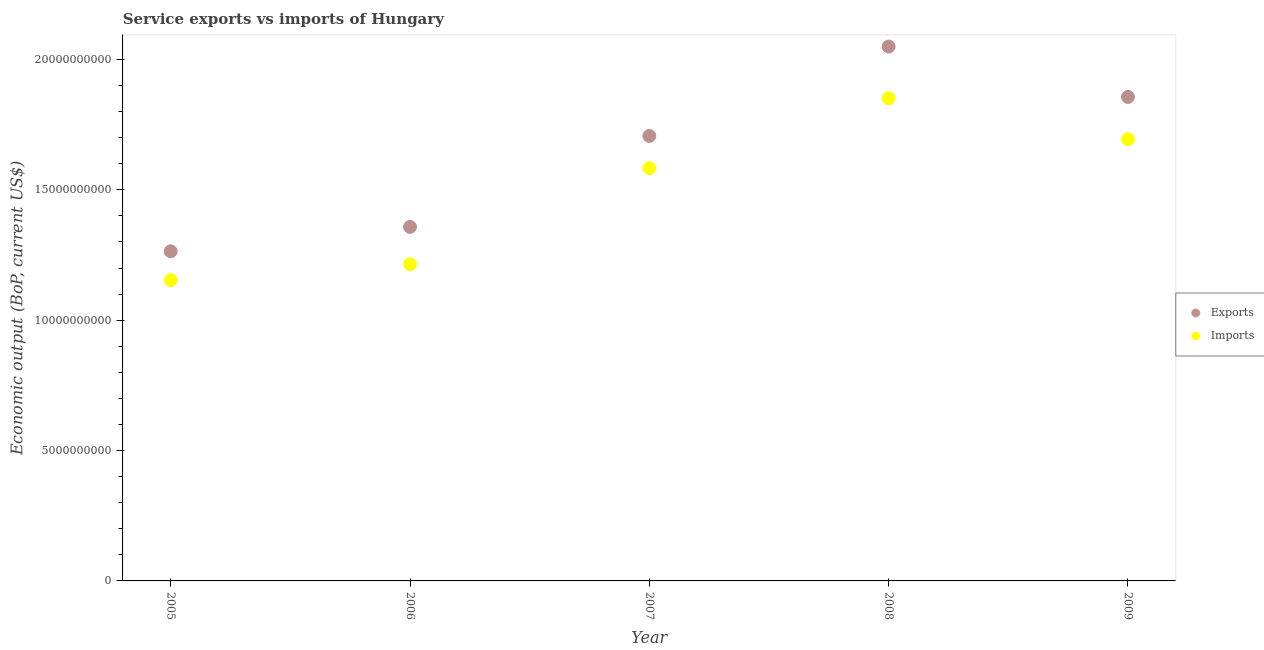How many different coloured dotlines are there?
Provide a short and direct response. 2. What is the amount of service imports in 2005?
Your answer should be very brief. 1.15e+1. Across all years, what is the maximum amount of service imports?
Offer a very short reply. 1.85e+1. Across all years, what is the minimum amount of service imports?
Your answer should be very brief. 1.15e+1. In which year was the amount of service imports minimum?
Your answer should be very brief. 2005. What is the total amount of service exports in the graph?
Your answer should be compact. 8.23e+1. What is the difference between the amount of service exports in 2005 and that in 2006?
Offer a terse response. -9.35e+08. What is the difference between the amount of service exports in 2007 and the amount of service imports in 2006?
Your answer should be compact. 4.92e+09. What is the average amount of service imports per year?
Make the answer very short. 1.50e+1. In the year 2009, what is the difference between the amount of service exports and amount of service imports?
Offer a very short reply. 1.62e+09. What is the ratio of the amount of service exports in 2006 to that in 2007?
Provide a short and direct response. 0.8. Is the difference between the amount of service imports in 2006 and 2008 greater than the difference between the amount of service exports in 2006 and 2008?
Offer a very short reply. Yes. What is the difference between the highest and the second highest amount of service imports?
Give a very brief answer. 1.57e+09. What is the difference between the highest and the lowest amount of service imports?
Keep it short and to the point. 6.98e+09. Is the sum of the amount of service imports in 2005 and 2007 greater than the maximum amount of service exports across all years?
Offer a very short reply. Yes. Is the amount of service exports strictly greater than the amount of service imports over the years?
Provide a succinct answer. Yes. Are the values on the major ticks of Y-axis written in scientific E-notation?
Give a very brief answer. No. Does the graph contain any zero values?
Offer a terse response. No. Does the graph contain grids?
Your answer should be compact. No. Where does the legend appear in the graph?
Provide a short and direct response. Center right. How many legend labels are there?
Your answer should be compact. 2. What is the title of the graph?
Offer a terse response. Service exports vs imports of Hungary. Does "Secondary" appear as one of the legend labels in the graph?
Offer a very short reply. No. What is the label or title of the X-axis?
Your answer should be compact. Year. What is the label or title of the Y-axis?
Ensure brevity in your answer.  Economic output (BoP, current US$). What is the Economic output (BoP, current US$) in Exports in 2005?
Ensure brevity in your answer.  1.26e+1. What is the Economic output (BoP, current US$) of Imports in 2005?
Keep it short and to the point. 1.15e+1. What is the Economic output (BoP, current US$) in Exports in 2006?
Your answer should be compact. 1.36e+1. What is the Economic output (BoP, current US$) of Imports in 2006?
Your response must be concise. 1.21e+1. What is the Economic output (BoP, current US$) of Exports in 2007?
Offer a very short reply. 1.71e+1. What is the Economic output (BoP, current US$) in Imports in 2007?
Provide a succinct answer. 1.58e+1. What is the Economic output (BoP, current US$) in Exports in 2008?
Your answer should be very brief. 2.05e+1. What is the Economic output (BoP, current US$) in Imports in 2008?
Offer a very short reply. 1.85e+1. What is the Economic output (BoP, current US$) in Exports in 2009?
Make the answer very short. 1.86e+1. What is the Economic output (BoP, current US$) in Imports in 2009?
Your answer should be very brief. 1.69e+1. Across all years, what is the maximum Economic output (BoP, current US$) in Exports?
Offer a terse response. 2.05e+1. Across all years, what is the maximum Economic output (BoP, current US$) in Imports?
Your response must be concise. 1.85e+1. Across all years, what is the minimum Economic output (BoP, current US$) in Exports?
Give a very brief answer. 1.26e+1. Across all years, what is the minimum Economic output (BoP, current US$) in Imports?
Your answer should be compact. 1.15e+1. What is the total Economic output (BoP, current US$) in Exports in the graph?
Your answer should be very brief. 8.23e+1. What is the total Economic output (BoP, current US$) of Imports in the graph?
Ensure brevity in your answer.  7.50e+1. What is the difference between the Economic output (BoP, current US$) of Exports in 2005 and that in 2006?
Make the answer very short. -9.35e+08. What is the difference between the Economic output (BoP, current US$) of Imports in 2005 and that in 2006?
Provide a succinct answer. -6.10e+08. What is the difference between the Economic output (BoP, current US$) of Exports in 2005 and that in 2007?
Your answer should be very brief. -4.42e+09. What is the difference between the Economic output (BoP, current US$) of Imports in 2005 and that in 2007?
Give a very brief answer. -4.30e+09. What is the difference between the Economic output (BoP, current US$) of Exports in 2005 and that in 2008?
Provide a short and direct response. -7.85e+09. What is the difference between the Economic output (BoP, current US$) in Imports in 2005 and that in 2008?
Your response must be concise. -6.98e+09. What is the difference between the Economic output (BoP, current US$) in Exports in 2005 and that in 2009?
Your answer should be compact. -5.92e+09. What is the difference between the Economic output (BoP, current US$) of Imports in 2005 and that in 2009?
Your answer should be very brief. -5.40e+09. What is the difference between the Economic output (BoP, current US$) in Exports in 2006 and that in 2007?
Your answer should be very brief. -3.49e+09. What is the difference between the Economic output (BoP, current US$) in Imports in 2006 and that in 2007?
Make the answer very short. -3.69e+09. What is the difference between the Economic output (BoP, current US$) of Exports in 2006 and that in 2008?
Your response must be concise. -6.92e+09. What is the difference between the Economic output (BoP, current US$) in Imports in 2006 and that in 2008?
Give a very brief answer. -6.37e+09. What is the difference between the Economic output (BoP, current US$) of Exports in 2006 and that in 2009?
Your answer should be compact. -4.98e+09. What is the difference between the Economic output (BoP, current US$) of Imports in 2006 and that in 2009?
Keep it short and to the point. -4.79e+09. What is the difference between the Economic output (BoP, current US$) in Exports in 2007 and that in 2008?
Your response must be concise. -3.43e+09. What is the difference between the Economic output (BoP, current US$) in Imports in 2007 and that in 2008?
Provide a short and direct response. -2.68e+09. What is the difference between the Economic output (BoP, current US$) of Exports in 2007 and that in 2009?
Provide a succinct answer. -1.50e+09. What is the difference between the Economic output (BoP, current US$) of Imports in 2007 and that in 2009?
Your answer should be very brief. -1.11e+09. What is the difference between the Economic output (BoP, current US$) of Exports in 2008 and that in 2009?
Ensure brevity in your answer.  1.93e+09. What is the difference between the Economic output (BoP, current US$) in Imports in 2008 and that in 2009?
Give a very brief answer. 1.57e+09. What is the difference between the Economic output (BoP, current US$) in Exports in 2005 and the Economic output (BoP, current US$) in Imports in 2006?
Keep it short and to the point. 4.97e+08. What is the difference between the Economic output (BoP, current US$) in Exports in 2005 and the Economic output (BoP, current US$) in Imports in 2007?
Provide a short and direct response. -3.19e+09. What is the difference between the Economic output (BoP, current US$) of Exports in 2005 and the Economic output (BoP, current US$) of Imports in 2008?
Offer a very short reply. -5.87e+09. What is the difference between the Economic output (BoP, current US$) of Exports in 2005 and the Economic output (BoP, current US$) of Imports in 2009?
Offer a very short reply. -4.30e+09. What is the difference between the Economic output (BoP, current US$) in Exports in 2006 and the Economic output (BoP, current US$) in Imports in 2007?
Your answer should be very brief. -2.25e+09. What is the difference between the Economic output (BoP, current US$) in Exports in 2006 and the Economic output (BoP, current US$) in Imports in 2008?
Offer a very short reply. -4.94e+09. What is the difference between the Economic output (BoP, current US$) in Exports in 2006 and the Economic output (BoP, current US$) in Imports in 2009?
Keep it short and to the point. -3.36e+09. What is the difference between the Economic output (BoP, current US$) in Exports in 2007 and the Economic output (BoP, current US$) in Imports in 2008?
Keep it short and to the point. -1.45e+09. What is the difference between the Economic output (BoP, current US$) of Exports in 2007 and the Economic output (BoP, current US$) of Imports in 2009?
Ensure brevity in your answer.  1.25e+08. What is the difference between the Economic output (BoP, current US$) in Exports in 2008 and the Economic output (BoP, current US$) in Imports in 2009?
Provide a short and direct response. 3.55e+09. What is the average Economic output (BoP, current US$) in Exports per year?
Make the answer very short. 1.65e+1. What is the average Economic output (BoP, current US$) of Imports per year?
Give a very brief answer. 1.50e+1. In the year 2005, what is the difference between the Economic output (BoP, current US$) in Exports and Economic output (BoP, current US$) in Imports?
Give a very brief answer. 1.11e+09. In the year 2006, what is the difference between the Economic output (BoP, current US$) in Exports and Economic output (BoP, current US$) in Imports?
Your answer should be compact. 1.43e+09. In the year 2007, what is the difference between the Economic output (BoP, current US$) in Exports and Economic output (BoP, current US$) in Imports?
Provide a short and direct response. 1.23e+09. In the year 2008, what is the difference between the Economic output (BoP, current US$) in Exports and Economic output (BoP, current US$) in Imports?
Your answer should be compact. 1.98e+09. In the year 2009, what is the difference between the Economic output (BoP, current US$) in Exports and Economic output (BoP, current US$) in Imports?
Your answer should be very brief. 1.62e+09. What is the ratio of the Economic output (BoP, current US$) of Exports in 2005 to that in 2006?
Offer a terse response. 0.93. What is the ratio of the Economic output (BoP, current US$) in Imports in 2005 to that in 2006?
Provide a short and direct response. 0.95. What is the ratio of the Economic output (BoP, current US$) in Exports in 2005 to that in 2007?
Your answer should be very brief. 0.74. What is the ratio of the Economic output (BoP, current US$) of Imports in 2005 to that in 2007?
Offer a terse response. 0.73. What is the ratio of the Economic output (BoP, current US$) of Exports in 2005 to that in 2008?
Ensure brevity in your answer.  0.62. What is the ratio of the Economic output (BoP, current US$) of Imports in 2005 to that in 2008?
Your answer should be very brief. 0.62. What is the ratio of the Economic output (BoP, current US$) of Exports in 2005 to that in 2009?
Your answer should be compact. 0.68. What is the ratio of the Economic output (BoP, current US$) of Imports in 2005 to that in 2009?
Keep it short and to the point. 0.68. What is the ratio of the Economic output (BoP, current US$) of Exports in 2006 to that in 2007?
Your answer should be very brief. 0.8. What is the ratio of the Economic output (BoP, current US$) in Imports in 2006 to that in 2007?
Your answer should be very brief. 0.77. What is the ratio of the Economic output (BoP, current US$) in Exports in 2006 to that in 2008?
Provide a short and direct response. 0.66. What is the ratio of the Economic output (BoP, current US$) of Imports in 2006 to that in 2008?
Your answer should be very brief. 0.66. What is the ratio of the Economic output (BoP, current US$) in Exports in 2006 to that in 2009?
Offer a terse response. 0.73. What is the ratio of the Economic output (BoP, current US$) in Imports in 2006 to that in 2009?
Your answer should be compact. 0.72. What is the ratio of the Economic output (BoP, current US$) in Exports in 2007 to that in 2008?
Make the answer very short. 0.83. What is the ratio of the Economic output (BoP, current US$) in Imports in 2007 to that in 2008?
Ensure brevity in your answer.  0.86. What is the ratio of the Economic output (BoP, current US$) in Exports in 2007 to that in 2009?
Your response must be concise. 0.92. What is the ratio of the Economic output (BoP, current US$) in Imports in 2007 to that in 2009?
Keep it short and to the point. 0.93. What is the ratio of the Economic output (BoP, current US$) of Exports in 2008 to that in 2009?
Provide a succinct answer. 1.1. What is the ratio of the Economic output (BoP, current US$) of Imports in 2008 to that in 2009?
Offer a very short reply. 1.09. What is the difference between the highest and the second highest Economic output (BoP, current US$) in Exports?
Provide a short and direct response. 1.93e+09. What is the difference between the highest and the second highest Economic output (BoP, current US$) in Imports?
Your answer should be compact. 1.57e+09. What is the difference between the highest and the lowest Economic output (BoP, current US$) of Exports?
Offer a very short reply. 7.85e+09. What is the difference between the highest and the lowest Economic output (BoP, current US$) in Imports?
Your answer should be compact. 6.98e+09. 